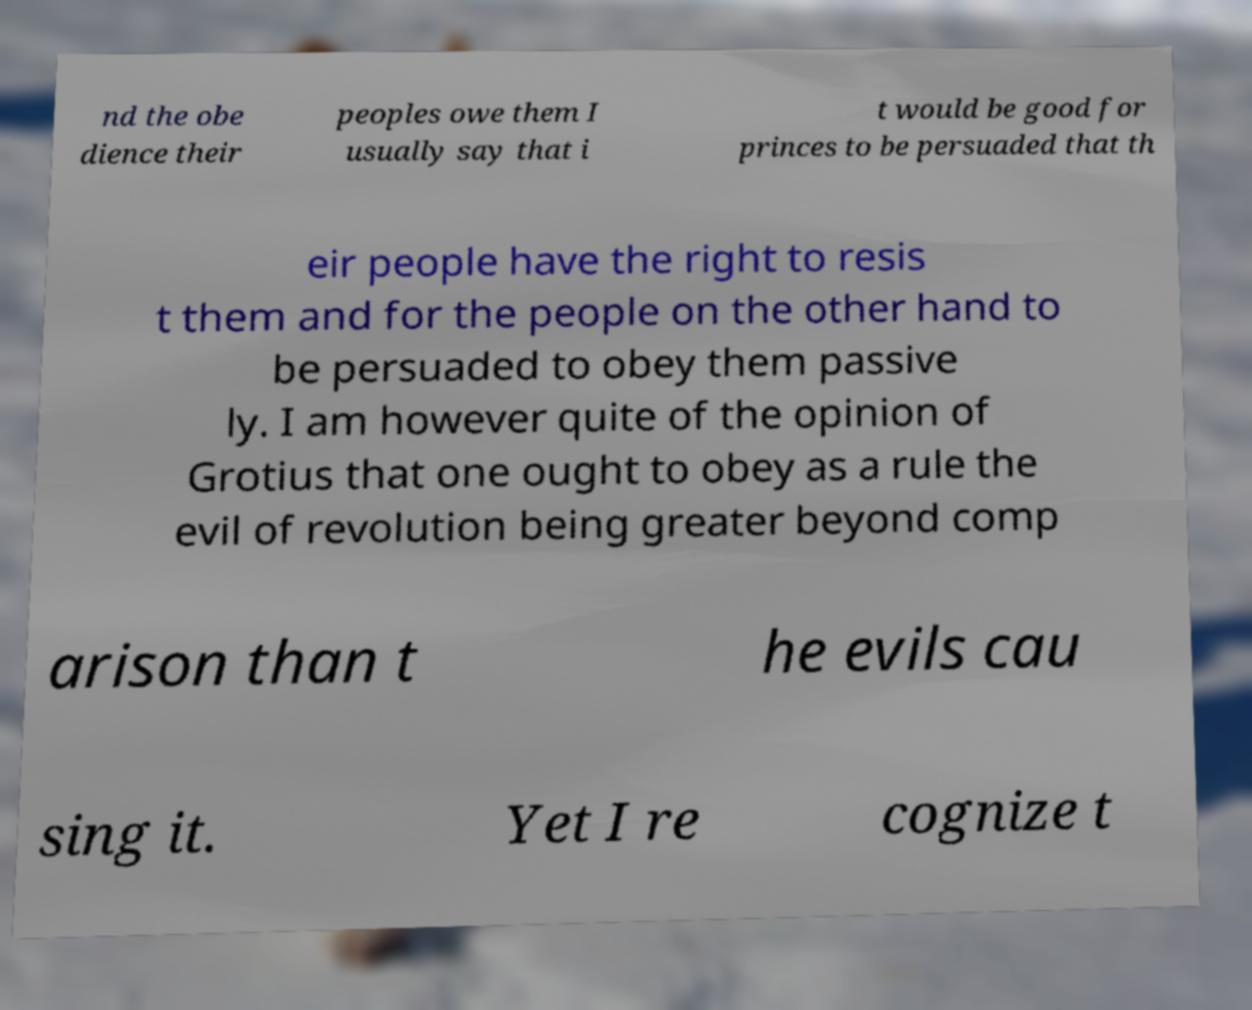For documentation purposes, I need the text within this image transcribed. Could you provide that? nd the obe dience their peoples owe them I usually say that i t would be good for princes to be persuaded that th eir people have the right to resis t them and for the people on the other hand to be persuaded to obey them passive ly. I am however quite of the opinion of Grotius that one ought to obey as a rule the evil of revolution being greater beyond comp arison than t he evils cau sing it. Yet I re cognize t 